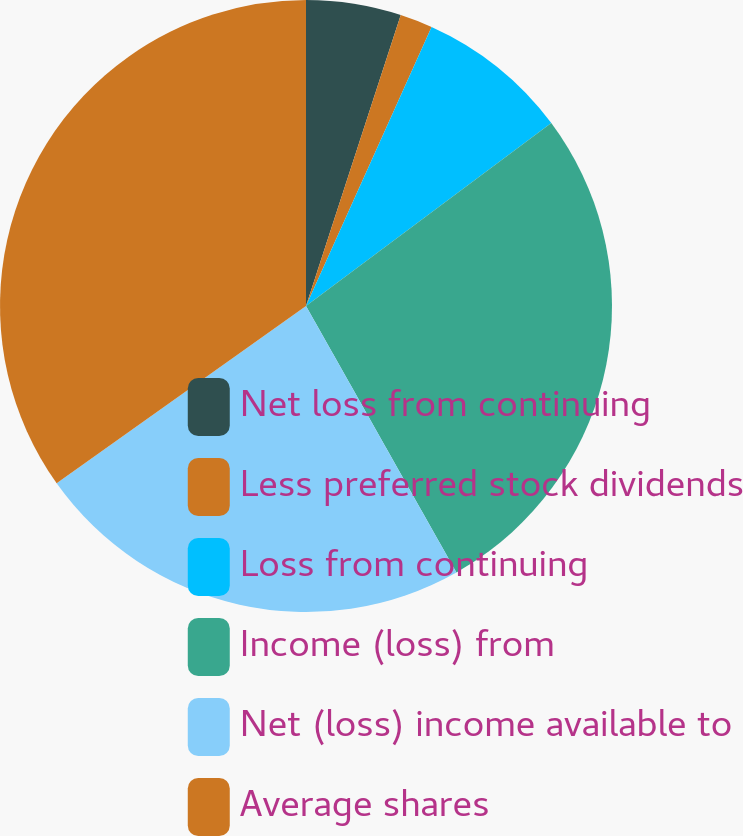Convert chart. <chart><loc_0><loc_0><loc_500><loc_500><pie_chart><fcel>Net loss from continuing<fcel>Less preferred stock dividends<fcel>Loss from continuing<fcel>Income (loss) from<fcel>Net (loss) income available to<fcel>Average shares<nl><fcel>5.01%<fcel>1.72%<fcel>8.07%<fcel>27.02%<fcel>23.34%<fcel>34.84%<nl></chart> 